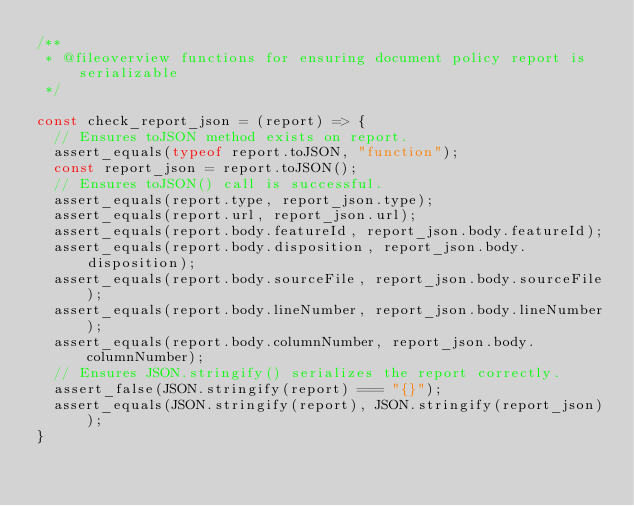Convert code to text. <code><loc_0><loc_0><loc_500><loc_500><_JavaScript_>/**
 * @fileoverview functions for ensuring document policy report is serializable
 */

const check_report_json = (report) => {
  // Ensures toJSON method exists on report.
  assert_equals(typeof report.toJSON, "function");
  const report_json = report.toJSON();
  // Ensures toJSON() call is successful.
  assert_equals(report.type, report_json.type);
  assert_equals(report.url, report_json.url);
  assert_equals(report.body.featureId, report_json.body.featureId);
  assert_equals(report.body.disposition, report_json.body.disposition);
  assert_equals(report.body.sourceFile, report_json.body.sourceFile);
  assert_equals(report.body.lineNumber, report_json.body.lineNumber);
  assert_equals(report.body.columnNumber, report_json.body.columnNumber);
  // Ensures JSON.stringify() serializes the report correctly.
  assert_false(JSON.stringify(report) === "{}");
  assert_equals(JSON.stringify(report), JSON.stringify(report_json));
}</code> 